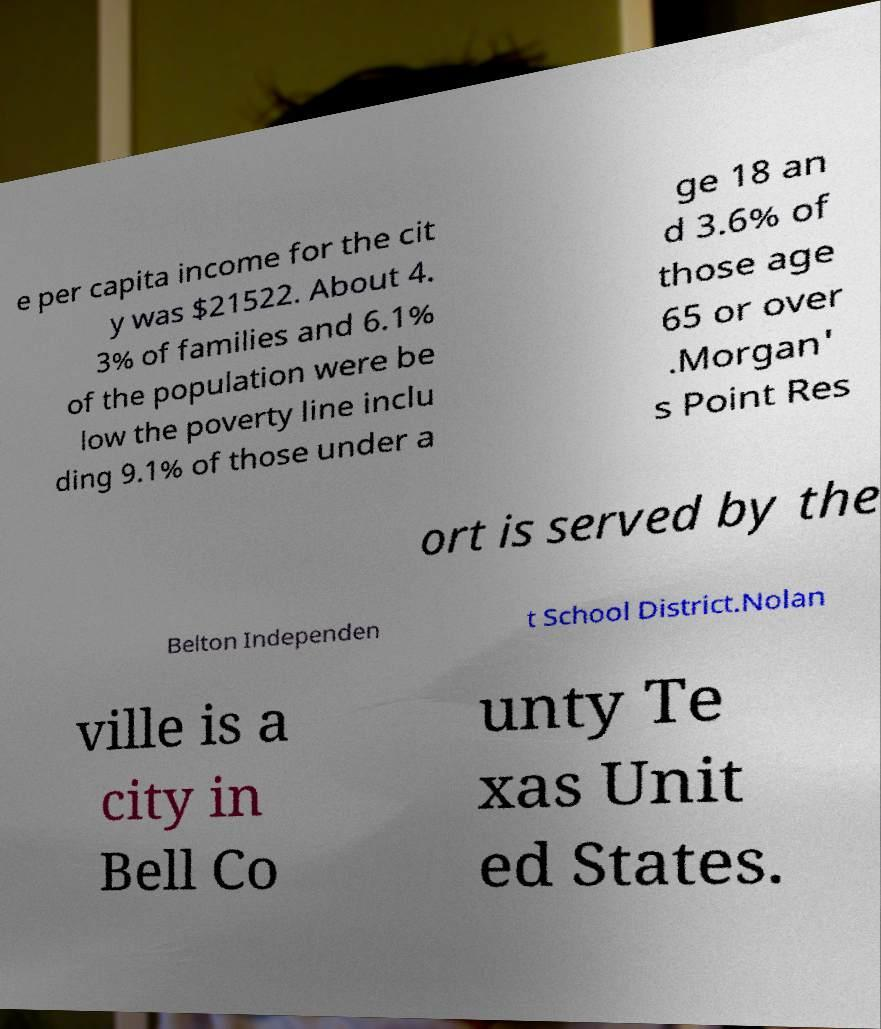Please identify and transcribe the text found in this image. e per capita income for the cit y was $21522. About 4. 3% of families and 6.1% of the population were be low the poverty line inclu ding 9.1% of those under a ge 18 an d 3.6% of those age 65 or over .Morgan' s Point Res ort is served by the Belton Independen t School District.Nolan ville is a city in Bell Co unty Te xas Unit ed States. 